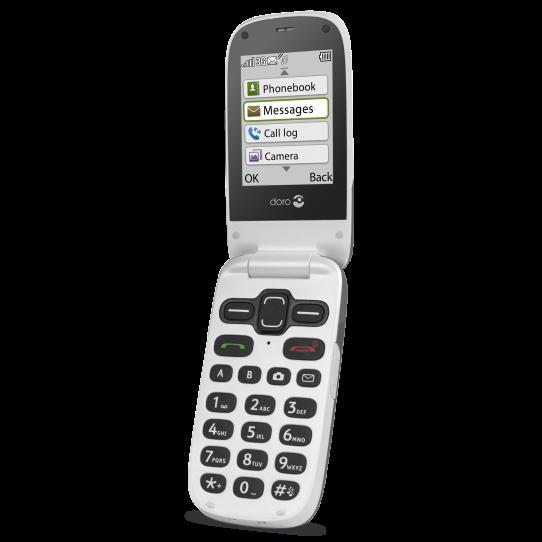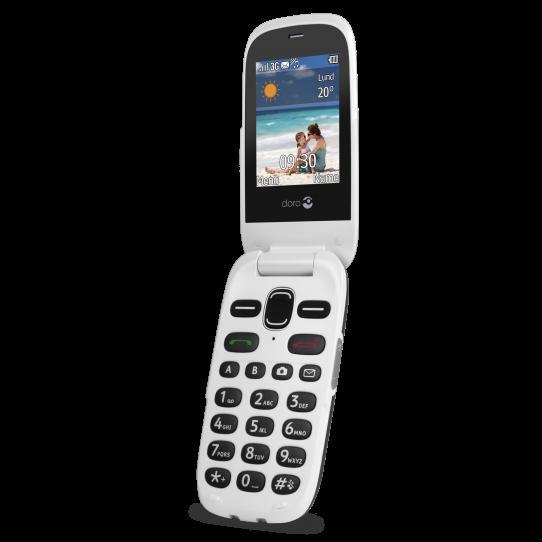The first image is the image on the left, the second image is the image on the right. Analyze the images presented: Is the assertion "Left and right images each show an open white flip phone with black buttons, rounded corners, and something displayed on the screen." valid? Answer yes or no. Yes. The first image is the image on the left, the second image is the image on the right. Assess this claim about the two images: "The phone in each image is flipped open to reveal the screen.". Correct or not? Answer yes or no. Yes. 